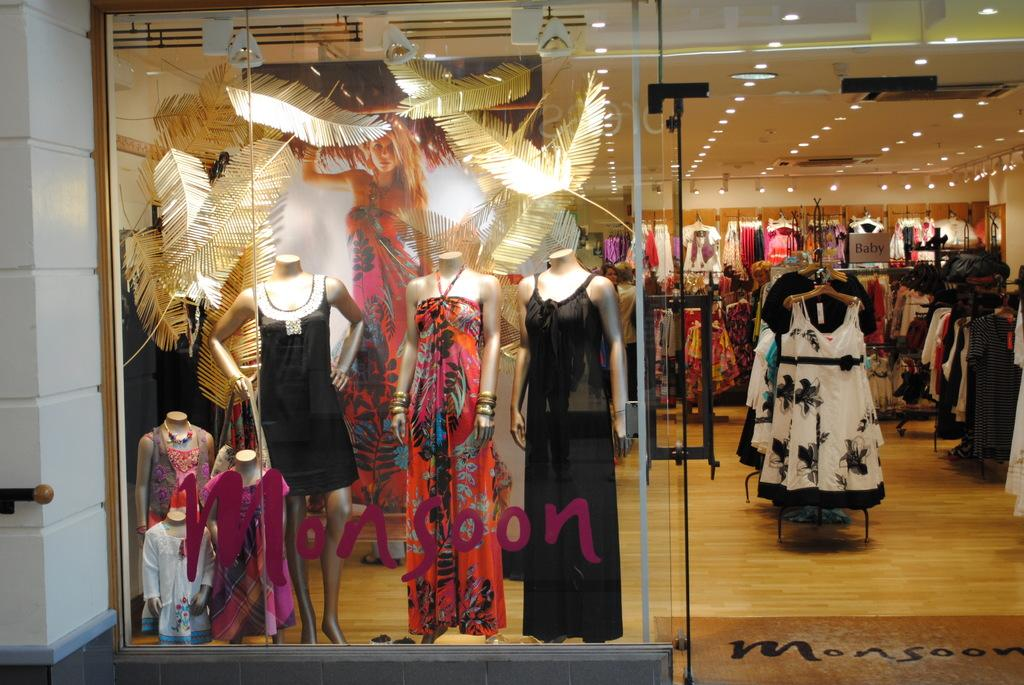What type of business is depicted in the image? There is a garment shop in the image. What can be seen inside the shop? There are clothes on display in the shop. What material is used for the flooring in the shop? The floor of the shop is furnished with wood. What color is used for the roof and walls of the shop? The roof and walls of the shop are white in color. Is there a net hanging from the roof in the image? No, there is no net hanging from the roof in the image. 